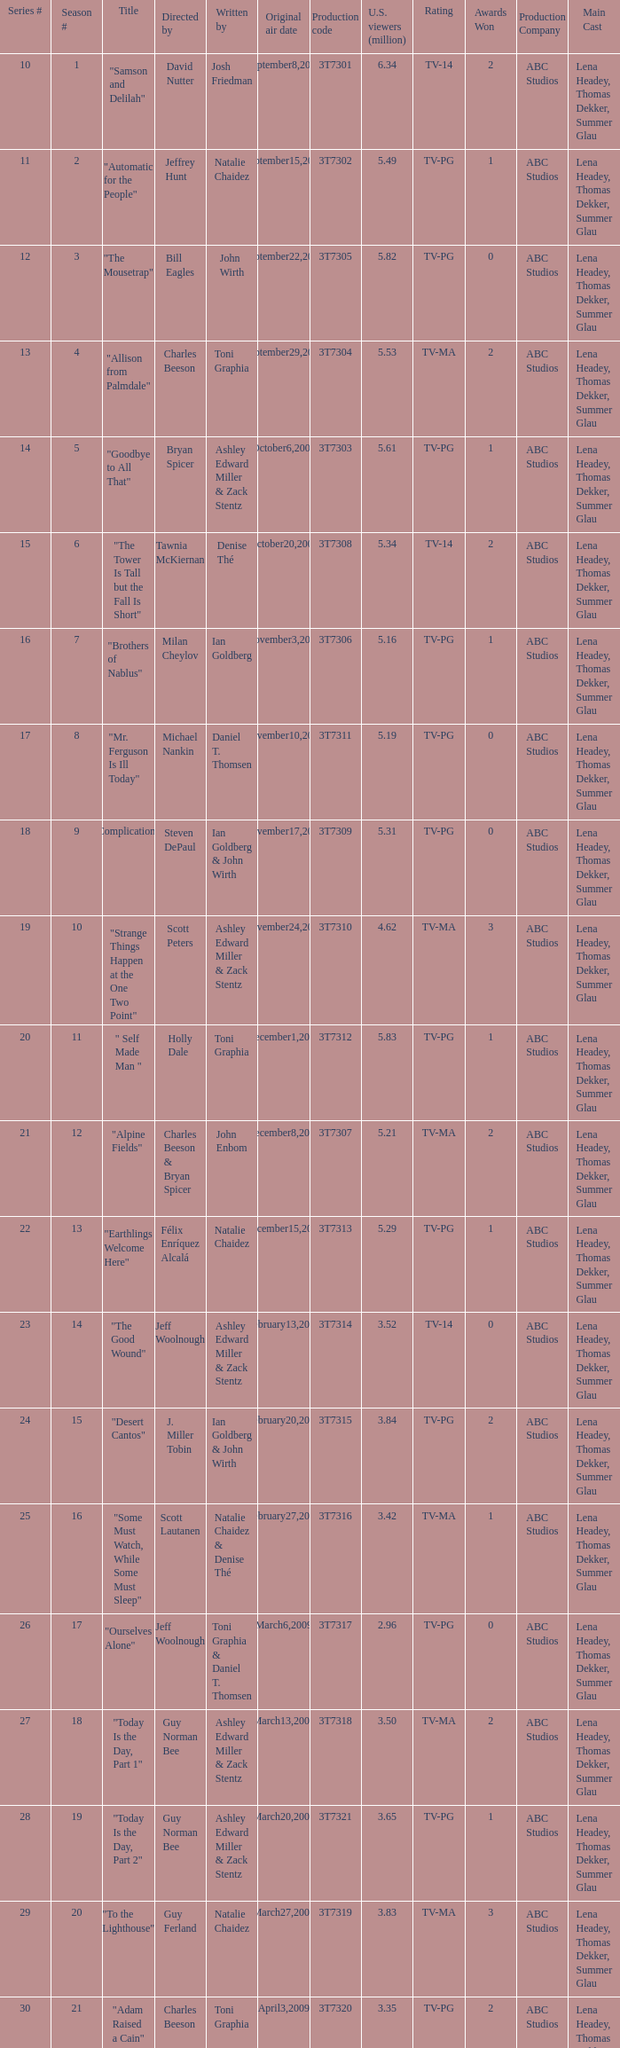Which episode number drew in 3.35 million viewers in the United States? 1.0. 